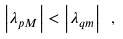<formula> <loc_0><loc_0><loc_500><loc_500>\left | \lambda _ { p M } \right | < \left | \lambda _ { q m } \right | \ ,</formula> 